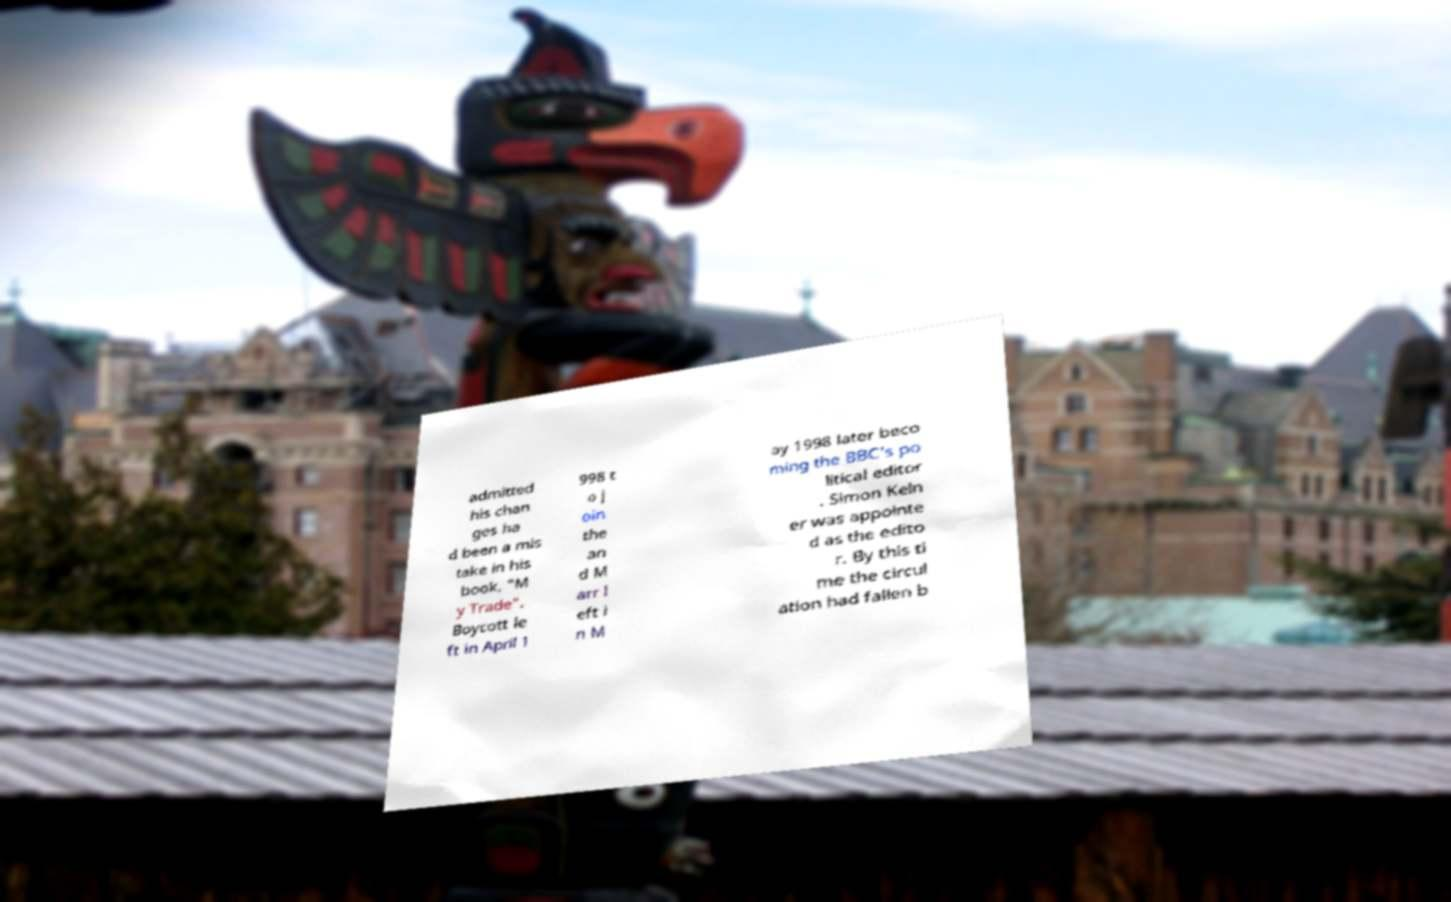Can you accurately transcribe the text from the provided image for me? admitted his chan ges ha d been a mis take in his book, "M y Trade". Boycott le ft in April 1 998 t o j oin the an d M arr l eft i n M ay 1998 later beco ming the BBC's po litical editor . Simon Keln er was appointe d as the edito r. By this ti me the circul ation had fallen b 